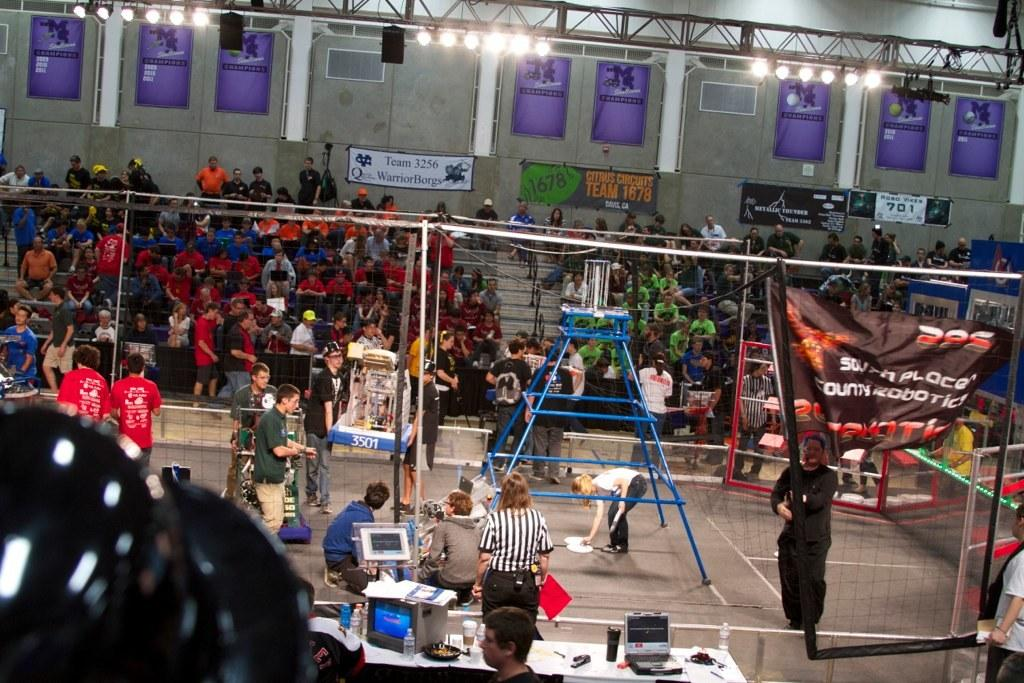What is the main subject of the image? The main subject of the image is a crowd of people. What are the people in the image doing? The people are sitting on chairs and standing in the image. What can be seen on the ceiling in the image? Lights are attached to the ceiling in the image. What type of engine is visible in the image? There is no engine present in the image; it features a crowd of people sitting on chairs and standing, with lights attached to the ceiling. 